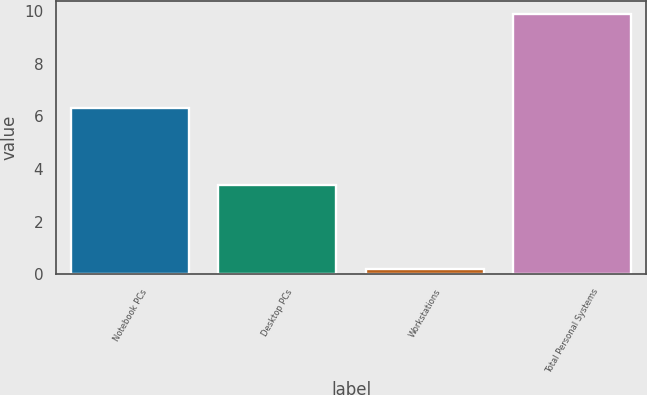Convert chart. <chart><loc_0><loc_0><loc_500><loc_500><bar_chart><fcel>Notebook PCs<fcel>Desktop PCs<fcel>Workstations<fcel>Total Personal Systems<nl><fcel>6.3<fcel>3.4<fcel>0.2<fcel>9.9<nl></chart> 